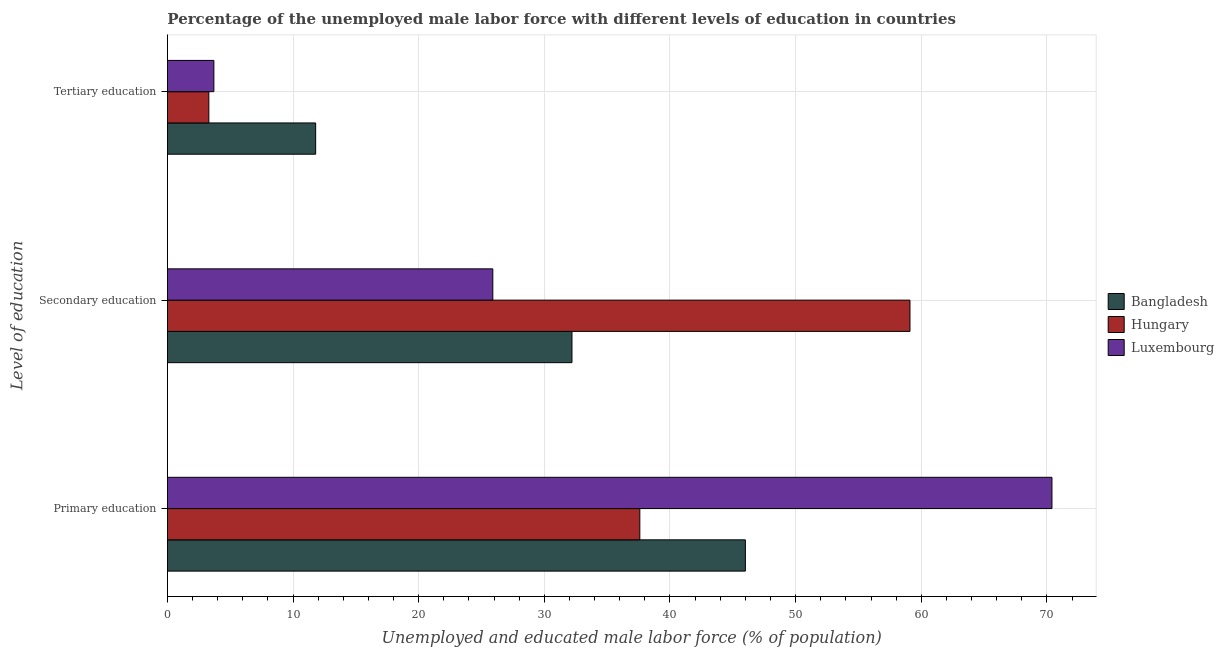How many groups of bars are there?
Your response must be concise. 3. Are the number of bars per tick equal to the number of legend labels?
Make the answer very short. Yes. How many bars are there on the 3rd tick from the top?
Your answer should be very brief. 3. How many bars are there on the 3rd tick from the bottom?
Offer a very short reply. 3. What is the percentage of male labor force who received tertiary education in Bangladesh?
Make the answer very short. 11.8. Across all countries, what is the maximum percentage of male labor force who received tertiary education?
Provide a succinct answer. 11.8. Across all countries, what is the minimum percentage of male labor force who received tertiary education?
Provide a short and direct response. 3.3. In which country was the percentage of male labor force who received secondary education minimum?
Your response must be concise. Luxembourg. What is the total percentage of male labor force who received tertiary education in the graph?
Provide a short and direct response. 18.8. What is the difference between the percentage of male labor force who received tertiary education in Hungary and that in Bangladesh?
Keep it short and to the point. -8.5. What is the difference between the percentage of male labor force who received primary education in Bangladesh and the percentage of male labor force who received secondary education in Luxembourg?
Your response must be concise. 20.1. What is the average percentage of male labor force who received secondary education per country?
Your answer should be compact. 39.07. What is the difference between the percentage of male labor force who received secondary education and percentage of male labor force who received primary education in Bangladesh?
Make the answer very short. -13.8. What is the ratio of the percentage of male labor force who received secondary education in Luxembourg to that in Hungary?
Your answer should be compact. 0.44. Is the percentage of male labor force who received primary education in Luxembourg less than that in Bangladesh?
Your response must be concise. No. What is the difference between the highest and the second highest percentage of male labor force who received secondary education?
Offer a terse response. 26.9. What is the difference between the highest and the lowest percentage of male labor force who received secondary education?
Provide a short and direct response. 33.2. In how many countries, is the percentage of male labor force who received tertiary education greater than the average percentage of male labor force who received tertiary education taken over all countries?
Make the answer very short. 1. Is the sum of the percentage of male labor force who received secondary education in Bangladesh and Hungary greater than the maximum percentage of male labor force who received tertiary education across all countries?
Your response must be concise. Yes. What does the 3rd bar from the top in Primary education represents?
Give a very brief answer. Bangladesh. Is it the case that in every country, the sum of the percentage of male labor force who received primary education and percentage of male labor force who received secondary education is greater than the percentage of male labor force who received tertiary education?
Give a very brief answer. Yes. How many bars are there?
Your answer should be very brief. 9. Are all the bars in the graph horizontal?
Provide a short and direct response. Yes. What is the difference between two consecutive major ticks on the X-axis?
Your answer should be very brief. 10. Are the values on the major ticks of X-axis written in scientific E-notation?
Ensure brevity in your answer.  No. Does the graph contain any zero values?
Make the answer very short. No. How many legend labels are there?
Provide a succinct answer. 3. How are the legend labels stacked?
Offer a very short reply. Vertical. What is the title of the graph?
Provide a succinct answer. Percentage of the unemployed male labor force with different levels of education in countries. What is the label or title of the X-axis?
Make the answer very short. Unemployed and educated male labor force (% of population). What is the label or title of the Y-axis?
Keep it short and to the point. Level of education. What is the Unemployed and educated male labor force (% of population) of Hungary in Primary education?
Your answer should be very brief. 37.6. What is the Unemployed and educated male labor force (% of population) of Luxembourg in Primary education?
Make the answer very short. 70.4. What is the Unemployed and educated male labor force (% of population) of Bangladesh in Secondary education?
Offer a terse response. 32.2. What is the Unemployed and educated male labor force (% of population) of Hungary in Secondary education?
Provide a succinct answer. 59.1. What is the Unemployed and educated male labor force (% of population) in Luxembourg in Secondary education?
Make the answer very short. 25.9. What is the Unemployed and educated male labor force (% of population) of Bangladesh in Tertiary education?
Your answer should be compact. 11.8. What is the Unemployed and educated male labor force (% of population) in Hungary in Tertiary education?
Offer a very short reply. 3.3. What is the Unemployed and educated male labor force (% of population) in Luxembourg in Tertiary education?
Ensure brevity in your answer.  3.7. Across all Level of education, what is the maximum Unemployed and educated male labor force (% of population) of Hungary?
Provide a short and direct response. 59.1. Across all Level of education, what is the maximum Unemployed and educated male labor force (% of population) of Luxembourg?
Ensure brevity in your answer.  70.4. Across all Level of education, what is the minimum Unemployed and educated male labor force (% of population) of Bangladesh?
Keep it short and to the point. 11.8. Across all Level of education, what is the minimum Unemployed and educated male labor force (% of population) in Hungary?
Your answer should be very brief. 3.3. Across all Level of education, what is the minimum Unemployed and educated male labor force (% of population) of Luxembourg?
Give a very brief answer. 3.7. What is the total Unemployed and educated male labor force (% of population) in Bangladesh in the graph?
Offer a terse response. 90. What is the total Unemployed and educated male labor force (% of population) of Hungary in the graph?
Your response must be concise. 100. What is the total Unemployed and educated male labor force (% of population) of Luxembourg in the graph?
Your answer should be compact. 100. What is the difference between the Unemployed and educated male labor force (% of population) of Bangladesh in Primary education and that in Secondary education?
Your answer should be compact. 13.8. What is the difference between the Unemployed and educated male labor force (% of population) of Hungary in Primary education and that in Secondary education?
Your answer should be very brief. -21.5. What is the difference between the Unemployed and educated male labor force (% of population) of Luxembourg in Primary education and that in Secondary education?
Provide a succinct answer. 44.5. What is the difference between the Unemployed and educated male labor force (% of population) in Bangladesh in Primary education and that in Tertiary education?
Provide a succinct answer. 34.2. What is the difference between the Unemployed and educated male labor force (% of population) in Hungary in Primary education and that in Tertiary education?
Your answer should be very brief. 34.3. What is the difference between the Unemployed and educated male labor force (% of population) in Luxembourg in Primary education and that in Tertiary education?
Give a very brief answer. 66.7. What is the difference between the Unemployed and educated male labor force (% of population) of Bangladesh in Secondary education and that in Tertiary education?
Keep it short and to the point. 20.4. What is the difference between the Unemployed and educated male labor force (% of population) in Hungary in Secondary education and that in Tertiary education?
Provide a short and direct response. 55.8. What is the difference between the Unemployed and educated male labor force (% of population) in Luxembourg in Secondary education and that in Tertiary education?
Provide a succinct answer. 22.2. What is the difference between the Unemployed and educated male labor force (% of population) in Bangladesh in Primary education and the Unemployed and educated male labor force (% of population) in Luxembourg in Secondary education?
Offer a terse response. 20.1. What is the difference between the Unemployed and educated male labor force (% of population) of Hungary in Primary education and the Unemployed and educated male labor force (% of population) of Luxembourg in Secondary education?
Offer a very short reply. 11.7. What is the difference between the Unemployed and educated male labor force (% of population) of Bangladesh in Primary education and the Unemployed and educated male labor force (% of population) of Hungary in Tertiary education?
Give a very brief answer. 42.7. What is the difference between the Unemployed and educated male labor force (% of population) in Bangladesh in Primary education and the Unemployed and educated male labor force (% of population) in Luxembourg in Tertiary education?
Your answer should be compact. 42.3. What is the difference between the Unemployed and educated male labor force (% of population) in Hungary in Primary education and the Unemployed and educated male labor force (% of population) in Luxembourg in Tertiary education?
Give a very brief answer. 33.9. What is the difference between the Unemployed and educated male labor force (% of population) in Bangladesh in Secondary education and the Unemployed and educated male labor force (% of population) in Hungary in Tertiary education?
Provide a short and direct response. 28.9. What is the difference between the Unemployed and educated male labor force (% of population) in Bangladesh in Secondary education and the Unemployed and educated male labor force (% of population) in Luxembourg in Tertiary education?
Keep it short and to the point. 28.5. What is the difference between the Unemployed and educated male labor force (% of population) in Hungary in Secondary education and the Unemployed and educated male labor force (% of population) in Luxembourg in Tertiary education?
Offer a very short reply. 55.4. What is the average Unemployed and educated male labor force (% of population) in Hungary per Level of education?
Provide a short and direct response. 33.33. What is the average Unemployed and educated male labor force (% of population) in Luxembourg per Level of education?
Your answer should be compact. 33.33. What is the difference between the Unemployed and educated male labor force (% of population) in Bangladesh and Unemployed and educated male labor force (% of population) in Hungary in Primary education?
Keep it short and to the point. 8.4. What is the difference between the Unemployed and educated male labor force (% of population) of Bangladesh and Unemployed and educated male labor force (% of population) of Luxembourg in Primary education?
Give a very brief answer. -24.4. What is the difference between the Unemployed and educated male labor force (% of population) of Hungary and Unemployed and educated male labor force (% of population) of Luxembourg in Primary education?
Make the answer very short. -32.8. What is the difference between the Unemployed and educated male labor force (% of population) in Bangladesh and Unemployed and educated male labor force (% of population) in Hungary in Secondary education?
Offer a terse response. -26.9. What is the difference between the Unemployed and educated male labor force (% of population) of Hungary and Unemployed and educated male labor force (% of population) of Luxembourg in Secondary education?
Offer a very short reply. 33.2. What is the difference between the Unemployed and educated male labor force (% of population) in Bangladesh and Unemployed and educated male labor force (% of population) in Hungary in Tertiary education?
Provide a succinct answer. 8.5. What is the difference between the Unemployed and educated male labor force (% of population) in Bangladesh and Unemployed and educated male labor force (% of population) in Luxembourg in Tertiary education?
Offer a terse response. 8.1. What is the ratio of the Unemployed and educated male labor force (% of population) of Bangladesh in Primary education to that in Secondary education?
Provide a succinct answer. 1.43. What is the ratio of the Unemployed and educated male labor force (% of population) of Hungary in Primary education to that in Secondary education?
Keep it short and to the point. 0.64. What is the ratio of the Unemployed and educated male labor force (% of population) of Luxembourg in Primary education to that in Secondary education?
Ensure brevity in your answer.  2.72. What is the ratio of the Unemployed and educated male labor force (% of population) in Bangladesh in Primary education to that in Tertiary education?
Your response must be concise. 3.9. What is the ratio of the Unemployed and educated male labor force (% of population) in Hungary in Primary education to that in Tertiary education?
Ensure brevity in your answer.  11.39. What is the ratio of the Unemployed and educated male labor force (% of population) in Luxembourg in Primary education to that in Tertiary education?
Provide a short and direct response. 19.03. What is the ratio of the Unemployed and educated male labor force (% of population) of Bangladesh in Secondary education to that in Tertiary education?
Offer a very short reply. 2.73. What is the ratio of the Unemployed and educated male labor force (% of population) of Hungary in Secondary education to that in Tertiary education?
Provide a succinct answer. 17.91. What is the ratio of the Unemployed and educated male labor force (% of population) of Luxembourg in Secondary education to that in Tertiary education?
Make the answer very short. 7. What is the difference between the highest and the second highest Unemployed and educated male labor force (% of population) of Bangladesh?
Give a very brief answer. 13.8. What is the difference between the highest and the second highest Unemployed and educated male labor force (% of population) of Hungary?
Your answer should be compact. 21.5. What is the difference between the highest and the second highest Unemployed and educated male labor force (% of population) of Luxembourg?
Your answer should be compact. 44.5. What is the difference between the highest and the lowest Unemployed and educated male labor force (% of population) of Bangladesh?
Ensure brevity in your answer.  34.2. What is the difference between the highest and the lowest Unemployed and educated male labor force (% of population) of Hungary?
Ensure brevity in your answer.  55.8. What is the difference between the highest and the lowest Unemployed and educated male labor force (% of population) in Luxembourg?
Provide a succinct answer. 66.7. 